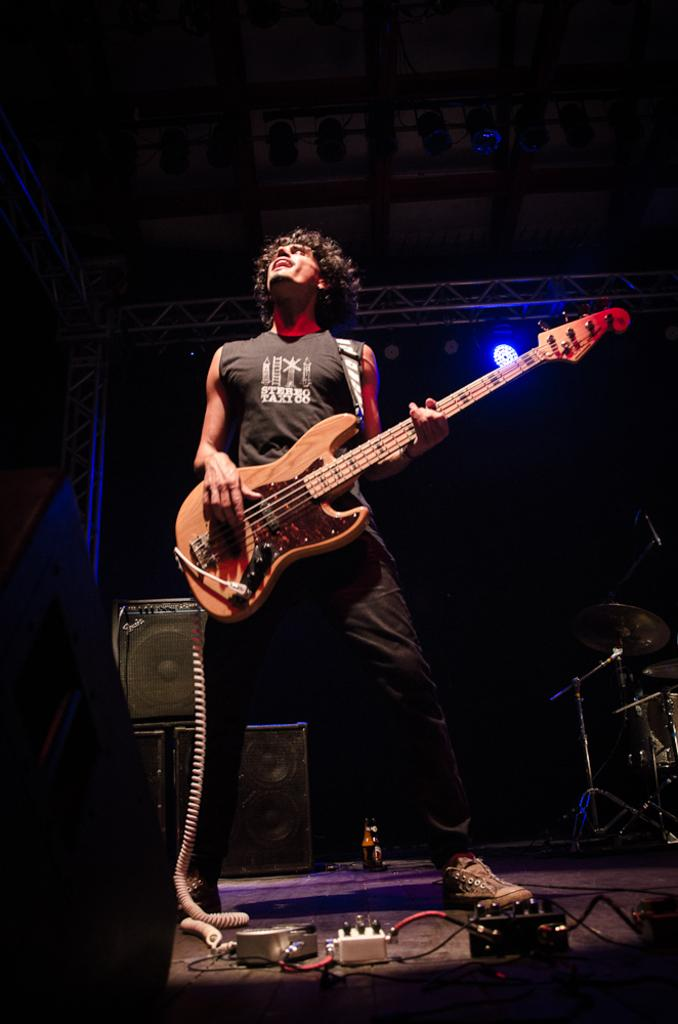What is the person in the image doing? The person is standing in the image and holding a guitar. What can be seen in the background of the image? There is a speaker, musical instruments, and a light in the background of the image. What might suggest that the person is involved in music? The presence of a guitar and musical instruments in the background suggests that the person is involved in music. How many dimes are scattered on the floor in the image? There are no dimes visible in the image. What type of temper does the person in the image have? There is no information about the person's temper in the image. 